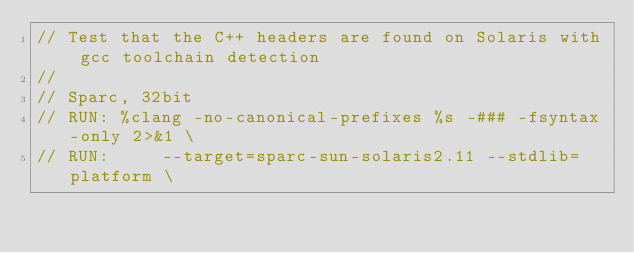Convert code to text. <code><loc_0><loc_0><loc_500><loc_500><_C++_>// Test that the C++ headers are found on Solaris with gcc toolchain detection
//
// Sparc, 32bit
// RUN: %clang -no-canonical-prefixes %s -### -fsyntax-only 2>&1 \
// RUN:     --target=sparc-sun-solaris2.11 --stdlib=platform \</code> 